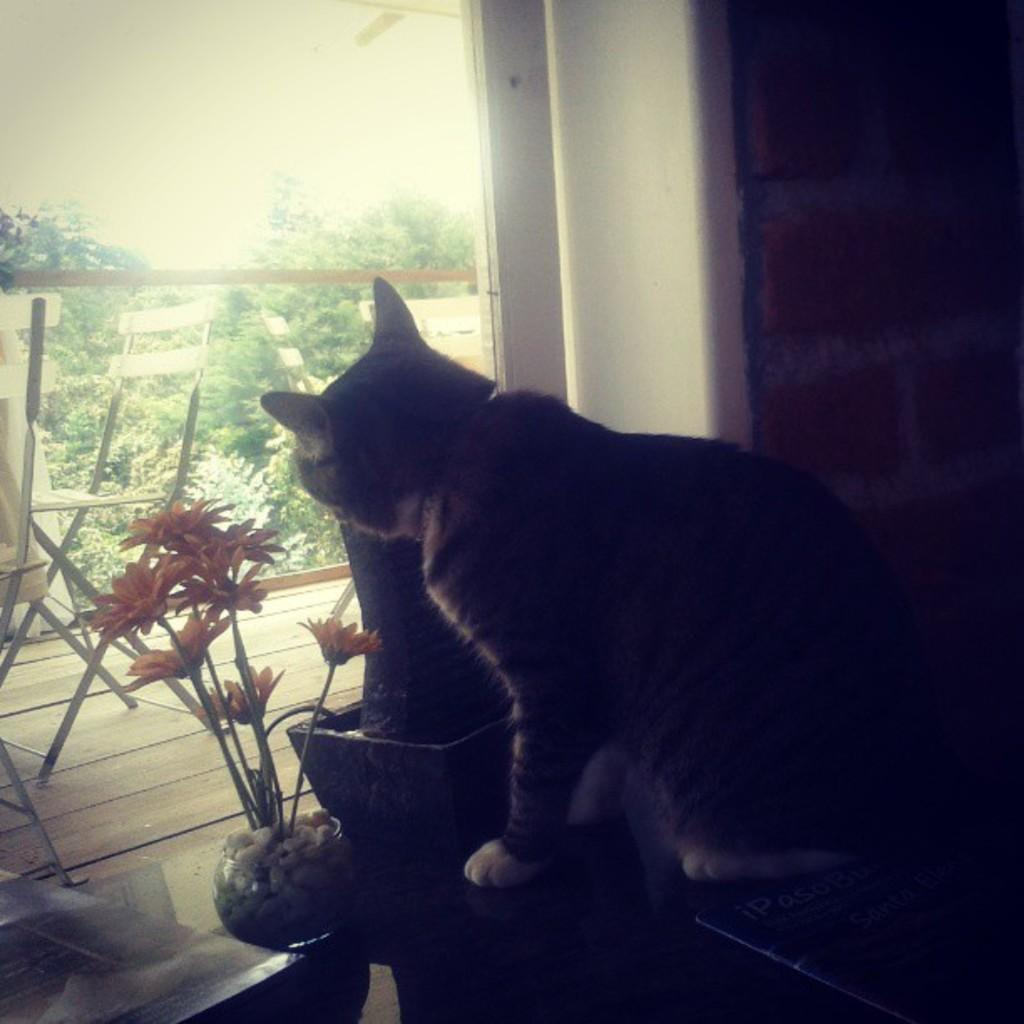What is located in the foreground of the image? There is a cat and a flower pot in the foreground of the image. What can be seen in the background of the image? There are chairs, railing, trees, and the sky visible in the background of the image. What type of behavior does the bird exhibit in the image? There is no bird present in the image, so it is not possible to describe its behavior. 